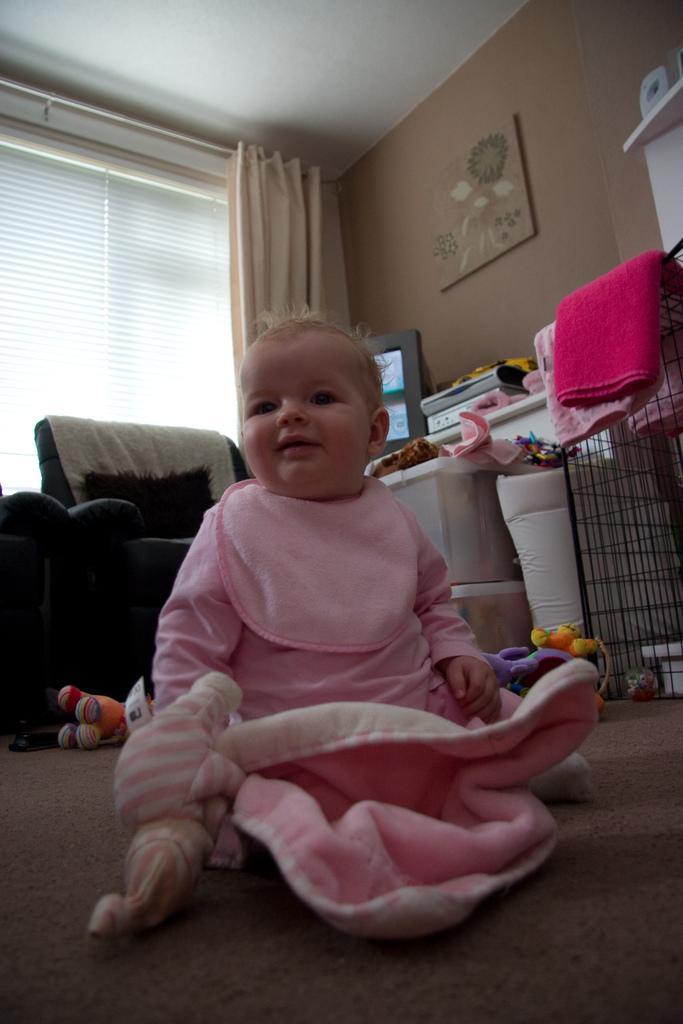Can you describe this image briefly? In this image I can see a baby wearing pink colored dress is sitting on the brown colored floor. In the background I can see a couch, few towels which are pink in color, a television screen, the window, the curtain, the wall, the ceiling and few toys on the floor. 